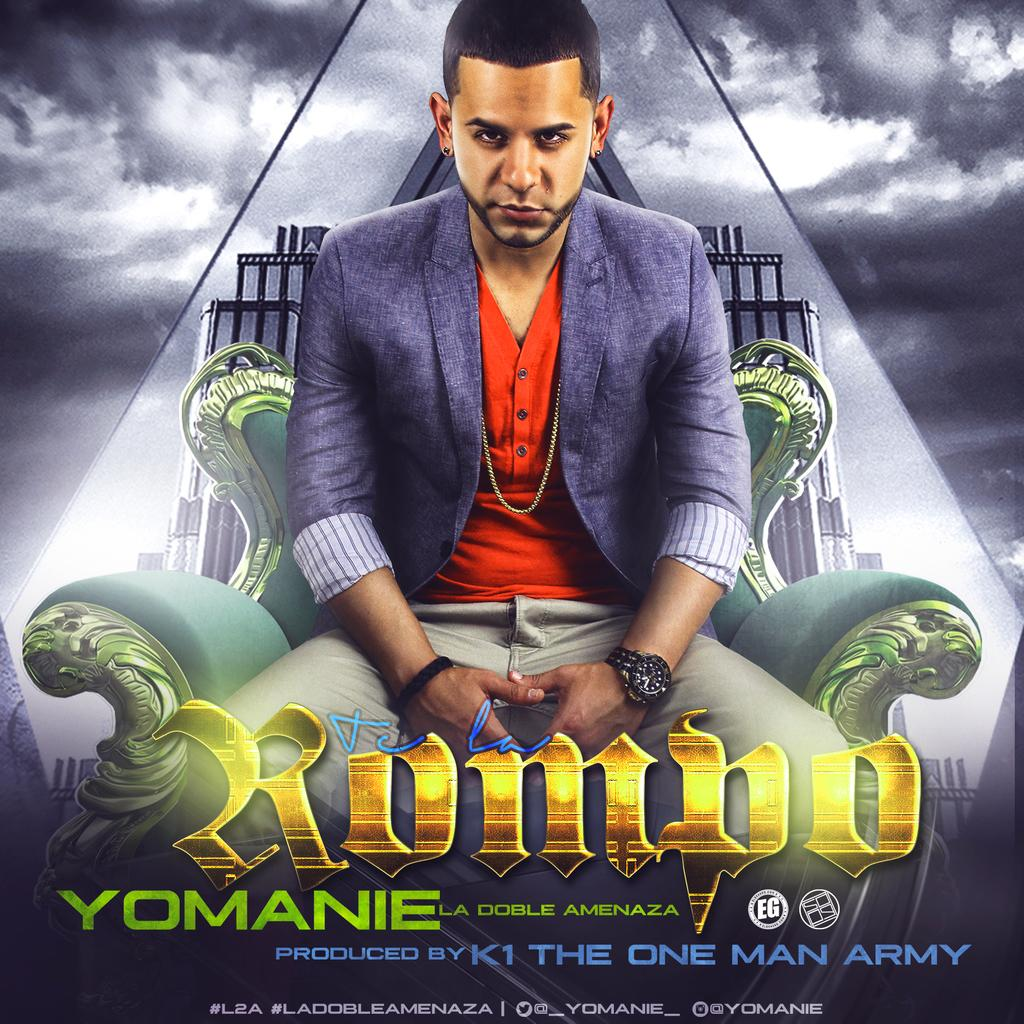What is the person in the image doing? There is a person sitting on a chair in the image. What can be seen on the poster in the image? There is something written on the poster. How would you describe the weather based on the image? The sky is cloudy in the image. What is visible in the background behind the person? There is a building visible behind the person. What type of canvas is the person painting on in the image? There is no canvas or painting activity present in the image. 